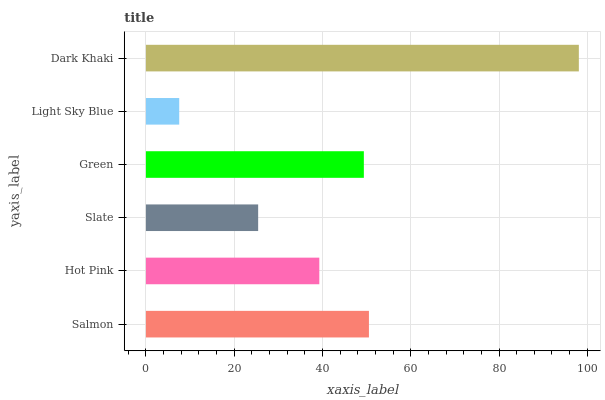Is Light Sky Blue the minimum?
Answer yes or no. Yes. Is Dark Khaki the maximum?
Answer yes or no. Yes. Is Hot Pink the minimum?
Answer yes or no. No. Is Hot Pink the maximum?
Answer yes or no. No. Is Salmon greater than Hot Pink?
Answer yes or no. Yes. Is Hot Pink less than Salmon?
Answer yes or no. Yes. Is Hot Pink greater than Salmon?
Answer yes or no. No. Is Salmon less than Hot Pink?
Answer yes or no. No. Is Green the high median?
Answer yes or no. Yes. Is Hot Pink the low median?
Answer yes or no. Yes. Is Dark Khaki the high median?
Answer yes or no. No. Is Green the low median?
Answer yes or no. No. 